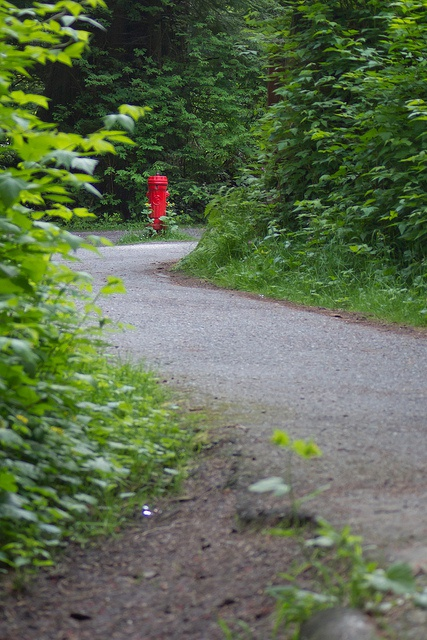Describe the objects in this image and their specific colors. I can see a fire hydrant in olive, brown, and maroon tones in this image. 